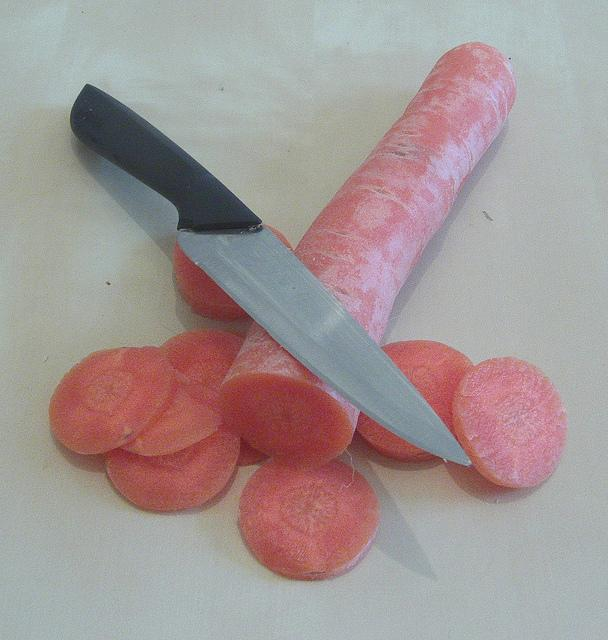What animal loves this food? Please explain your reasoning. rabbit. These are the vegetation they eat 